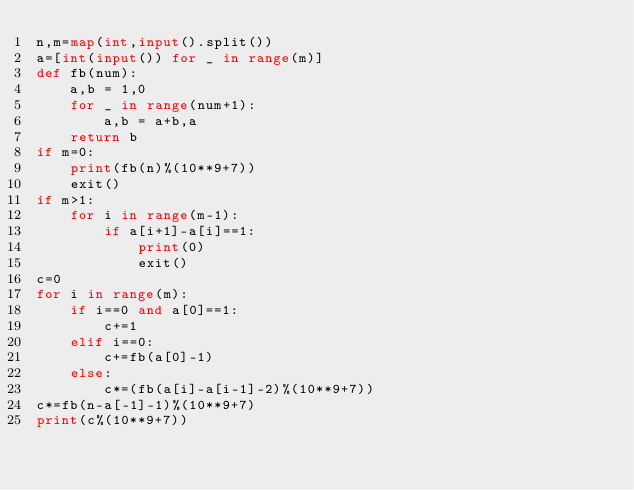Convert code to text. <code><loc_0><loc_0><loc_500><loc_500><_Python_>n,m=map(int,input().split())
a=[int(input()) for _ in range(m)]
def fb(num):
    a,b = 1,0
    for _ in range(num+1):
        a,b = a+b,a
    return b
if m=0:
    print(fb(n)%(10**9+7))
    exit()
if m>1:
    for i in range(m-1):
        if a[i+1]-a[i]==1:
            print(0)
            exit()
c=0
for i in range(m):
    if i==0 and a[0]==1:
        c+=1
    elif i==0:
        c+=fb(a[0]-1)
    else:
        c*=(fb(a[i]-a[i-1]-2)%(10**9+7))
c*=fb(n-a[-1]-1)%(10**9+7)
print(c%(10**9+7))</code> 